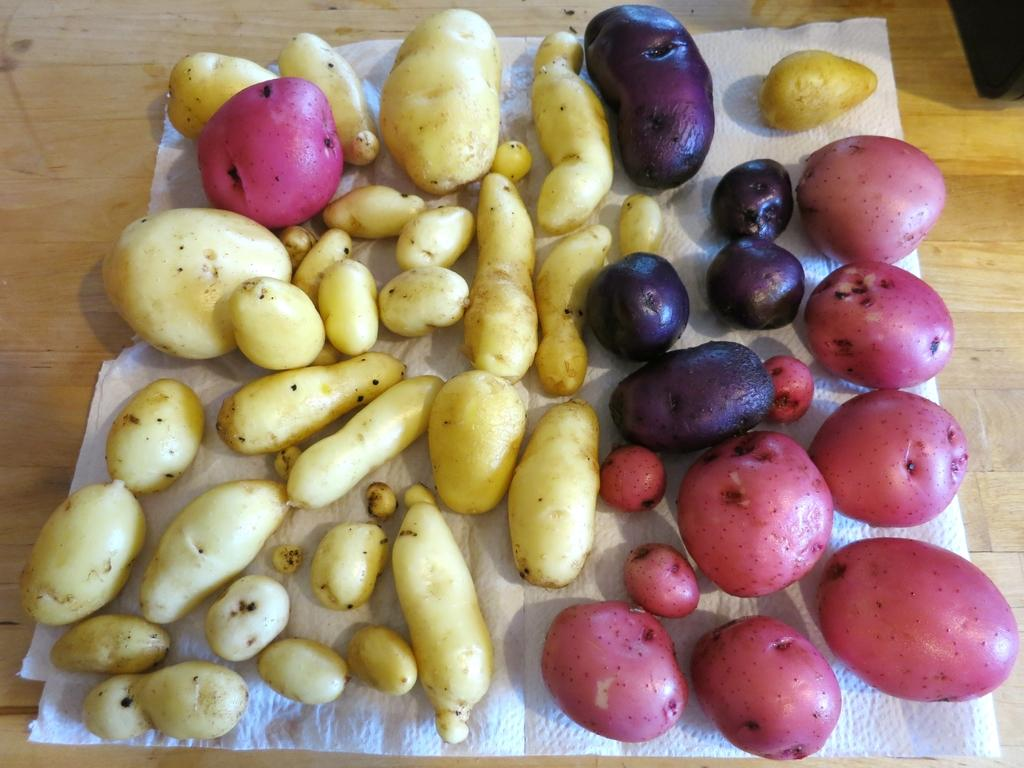What is the primary surface visible in the image? There is a floor in the image. Is there any additional covering on the floor? Yes, there is a mat on the floor. What can be found on the mat? There are food items on the mat. What type of chin can be seen on the food items in the image? There is no chin present in the image, as the food items are not depicted as having faces or any other features that would include a chin. 